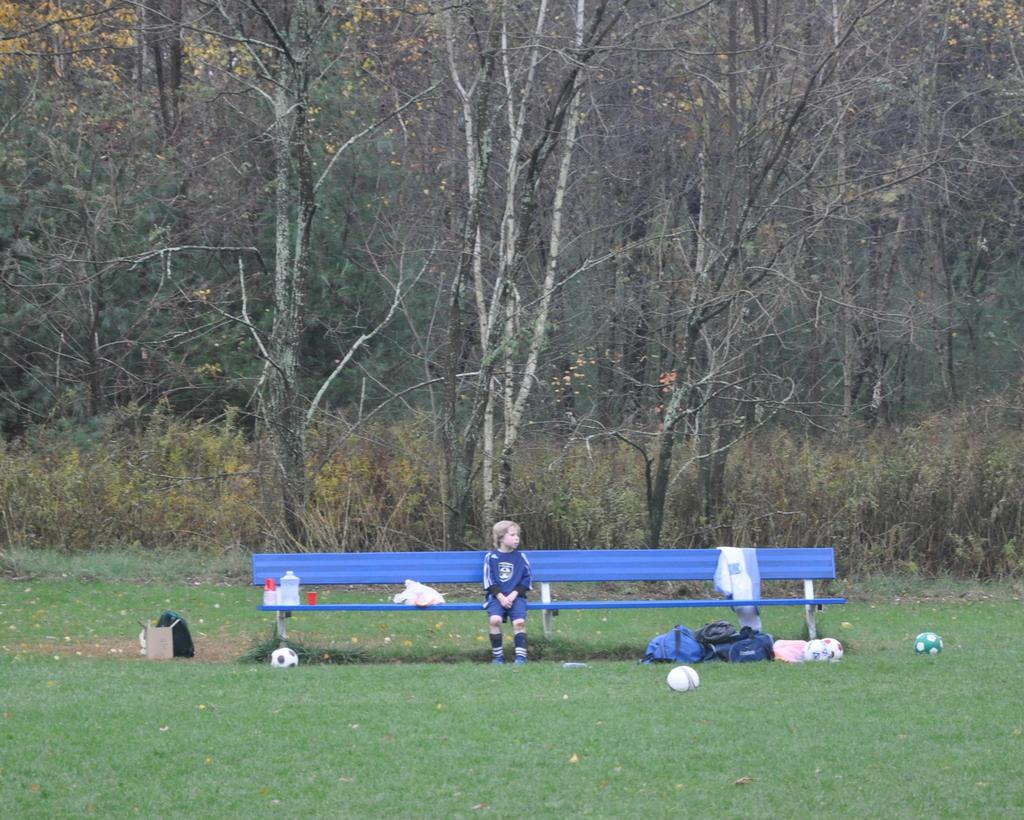What is the child doing in the image? The child is sitting on a bench in the image. What items can be seen near the child? There are bags and balls visible in the image. What type of surface is the child sitting on? The child is sitting on a bench. What can be seen in the background of the image? There are trees in the background of the image. What type of environment is depicted in the image? The image shows a grassy area, suggesting an outdoor setting. What color is the crayon being used by the child in the image? There is no crayon present in the image. What type of science experiment is being conducted in the image? There is no science experiment depicted in the image. 